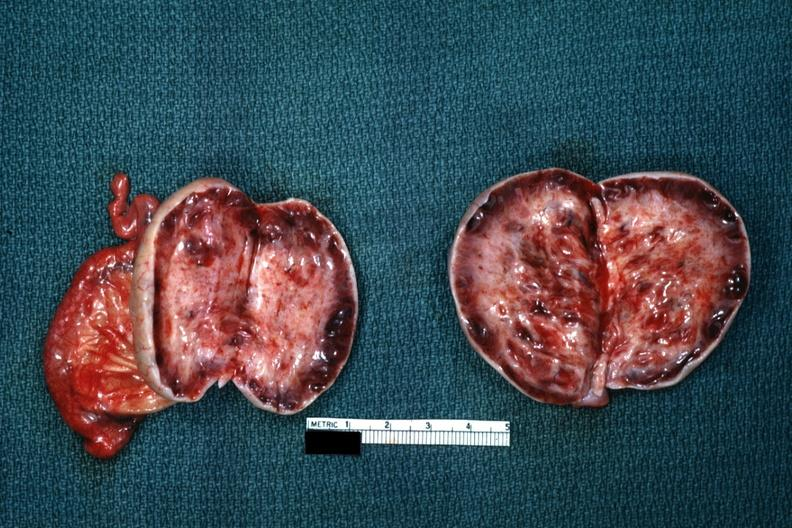does this image show thick capsule with some cysts?
Answer the question using a single word or phrase. Yes 